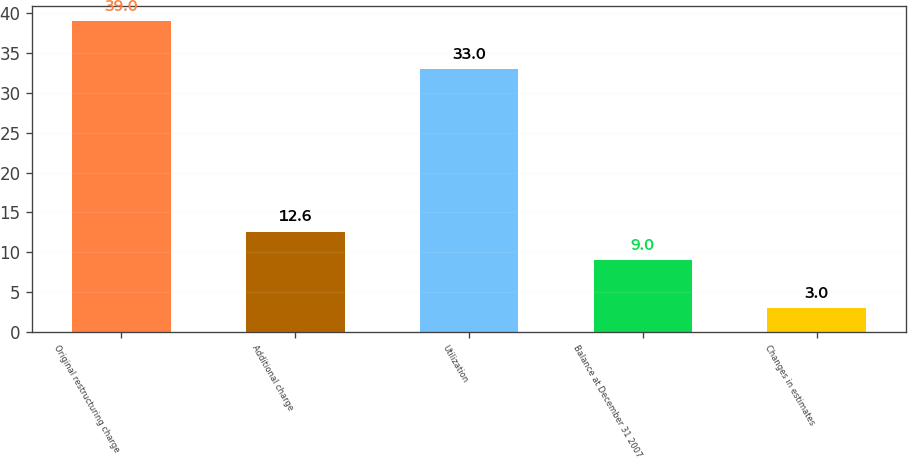Convert chart to OTSL. <chart><loc_0><loc_0><loc_500><loc_500><bar_chart><fcel>Original restructuring charge<fcel>Additional charge<fcel>Utilization<fcel>Balance at December 31 2007<fcel>Changes in estimates<nl><fcel>39<fcel>12.6<fcel>33<fcel>9<fcel>3<nl></chart> 